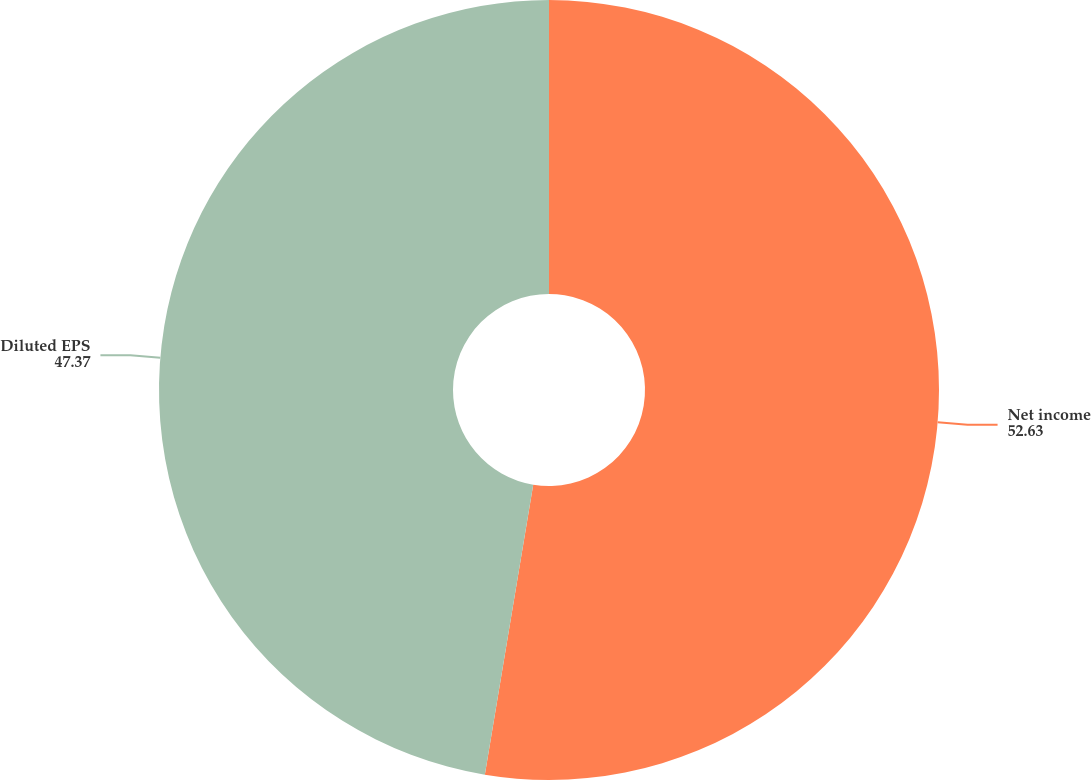Convert chart. <chart><loc_0><loc_0><loc_500><loc_500><pie_chart><fcel>Net income<fcel>Diluted EPS<nl><fcel>52.63%<fcel>47.37%<nl></chart> 